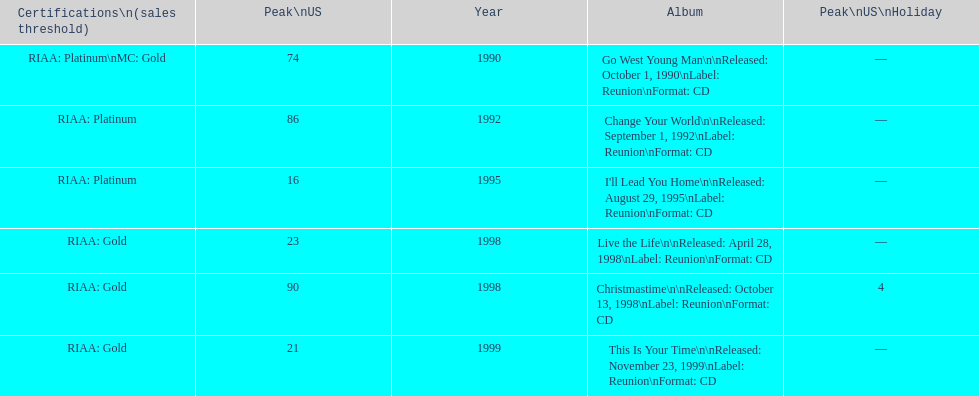Which michael w smith album had the highest ranking on the us chart? I'll Lead You Home. 